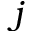<formula> <loc_0><loc_0><loc_500><loc_500>j</formula> 